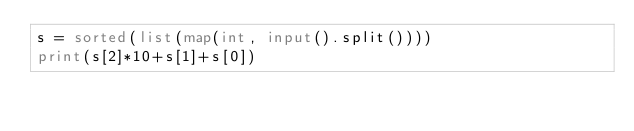<code> <loc_0><loc_0><loc_500><loc_500><_Python_>s = sorted(list(map(int, input().split())))
print(s[2]*10+s[1]+s[0])</code> 